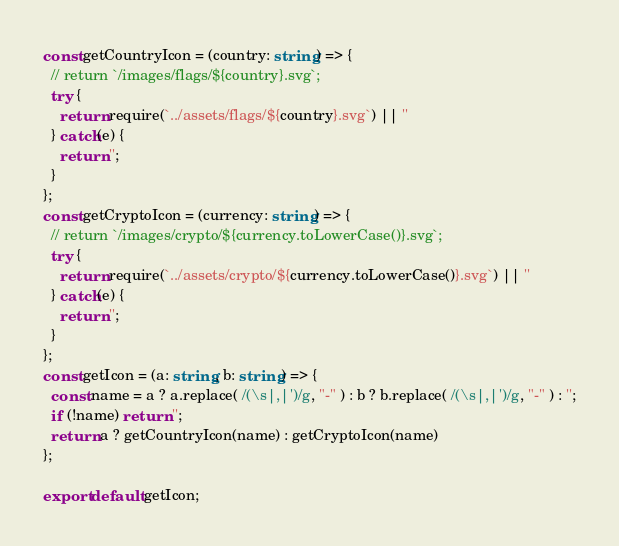<code> <loc_0><loc_0><loc_500><loc_500><_TypeScript_>const getCountryIcon = (country: string) => {
  // return `/images/flags/${country}.svg`;
  try {
    return require(`../assets/flags/${country}.svg`) || ''
  } catch(e) {
    return '';
  }
};
const getCryptoIcon = (currency: string) => {
  // return `/images/crypto/${currency.toLowerCase()}.svg`;
  try {
    return require(`../assets/crypto/${currency.toLowerCase()}.svg`) || ''
  } catch(e) {
    return '';
  }
};
const getIcon = (a: string, b: string) => {
  const name = a ? a.replace( /(\s|,|')/g, "-" ) : b ? b.replace( /(\s|,|')/g, "-" ) : '';
  if (!name) return '';
  return a ? getCountryIcon(name) : getCryptoIcon(name)
};

export default getIcon;</code> 